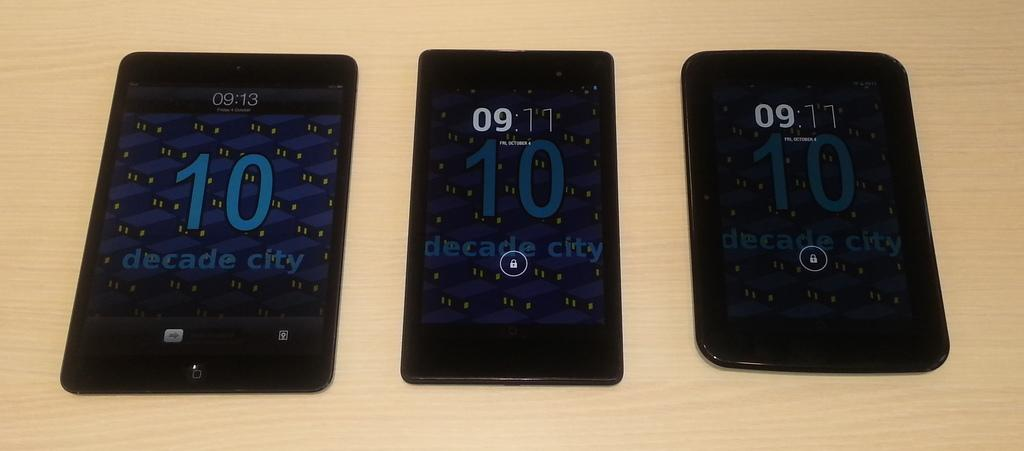Provide a one-sentence caption for the provided image. Three black cell phones laying in a row, one displaying the time as 09:13 with the others showing 09:11. 